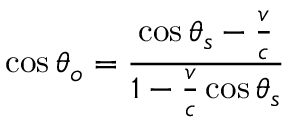Convert formula to latex. <formula><loc_0><loc_0><loc_500><loc_500>\cos \theta _ { o } = { \frac { \cos \theta _ { s } - { \frac { v } { c } } } { 1 - { \frac { v } { c } } \cos \theta _ { s } } }</formula> 